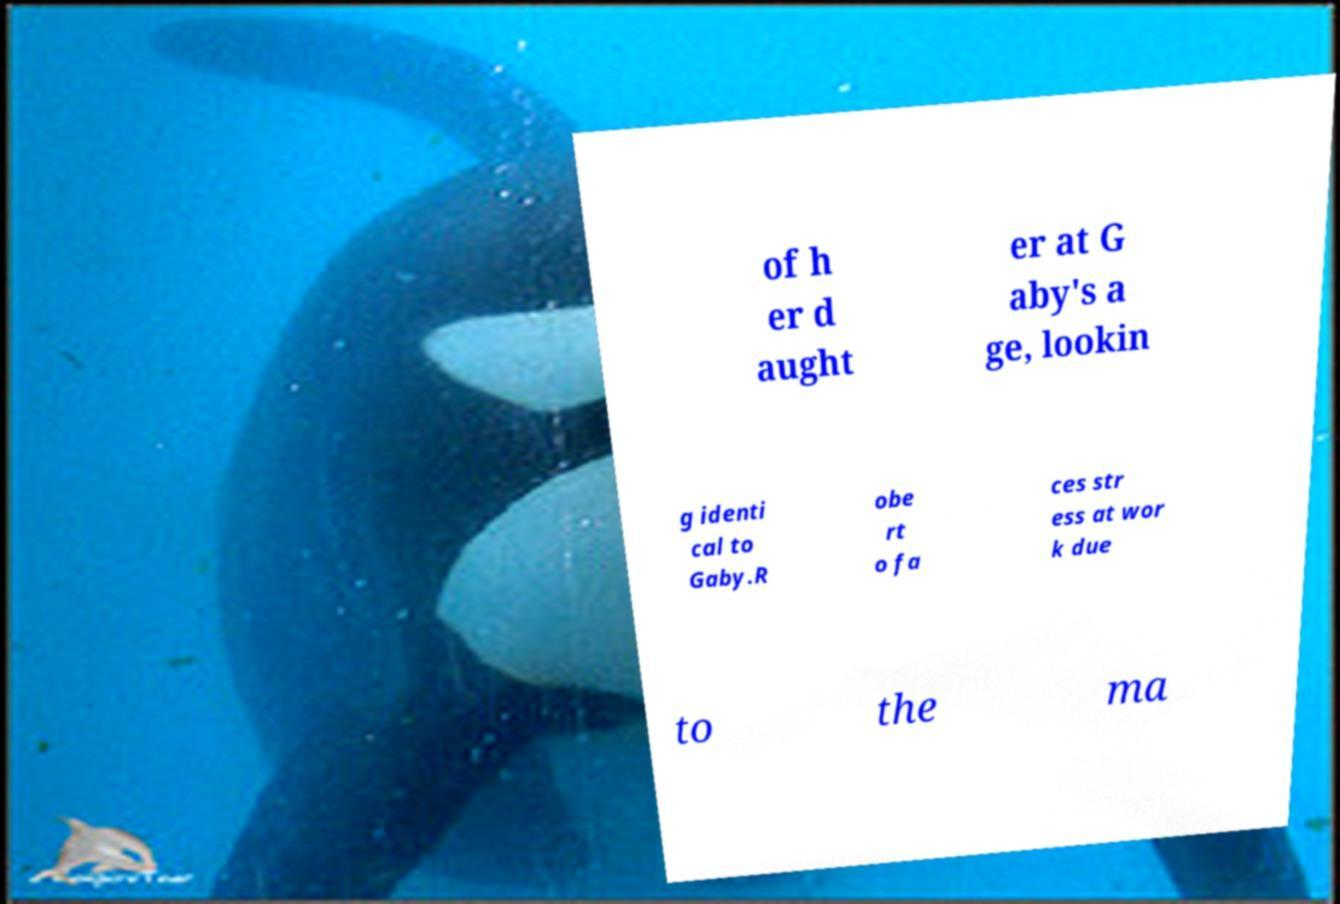For documentation purposes, I need the text within this image transcribed. Could you provide that? of h er d aught er at G aby's a ge, lookin g identi cal to Gaby.R obe rt o fa ces str ess at wor k due to the ma 